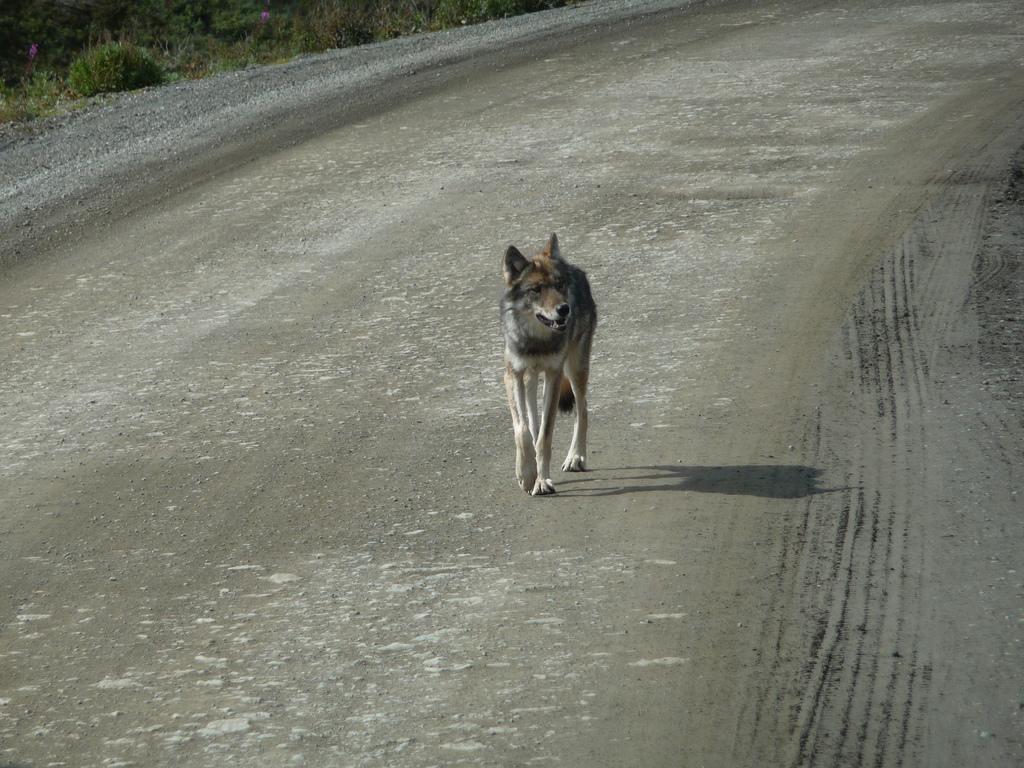Can you describe this image briefly? In this image we can see a dog on the road and also we can see the grass. 